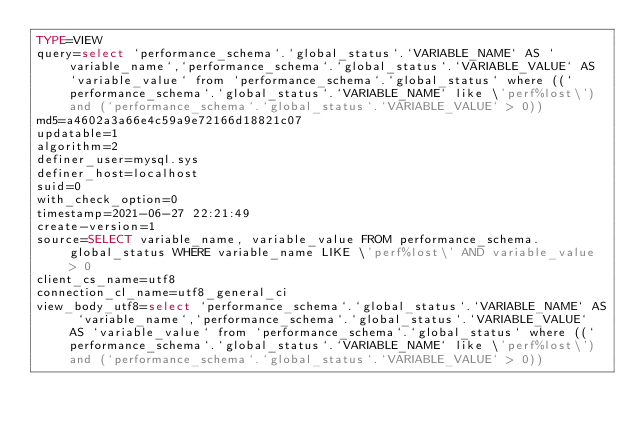<code> <loc_0><loc_0><loc_500><loc_500><_VisualBasic_>TYPE=VIEW
query=select `performance_schema`.`global_status`.`VARIABLE_NAME` AS `variable_name`,`performance_schema`.`global_status`.`VARIABLE_VALUE` AS `variable_value` from `performance_schema`.`global_status` where ((`performance_schema`.`global_status`.`VARIABLE_NAME` like \'perf%lost\') and (`performance_schema`.`global_status`.`VARIABLE_VALUE` > 0))
md5=a4602a3a66e4c59a9e72166d18821c07
updatable=1
algorithm=2
definer_user=mysql.sys
definer_host=localhost
suid=0
with_check_option=0
timestamp=2021-06-27 22:21:49
create-version=1
source=SELECT variable_name, variable_value FROM performance_schema.global_status WHERE variable_name LIKE \'perf%lost\' AND variable_value > 0
client_cs_name=utf8
connection_cl_name=utf8_general_ci
view_body_utf8=select `performance_schema`.`global_status`.`VARIABLE_NAME` AS `variable_name`,`performance_schema`.`global_status`.`VARIABLE_VALUE` AS `variable_value` from `performance_schema`.`global_status` where ((`performance_schema`.`global_status`.`VARIABLE_NAME` like \'perf%lost\') and (`performance_schema`.`global_status`.`VARIABLE_VALUE` > 0))
</code> 